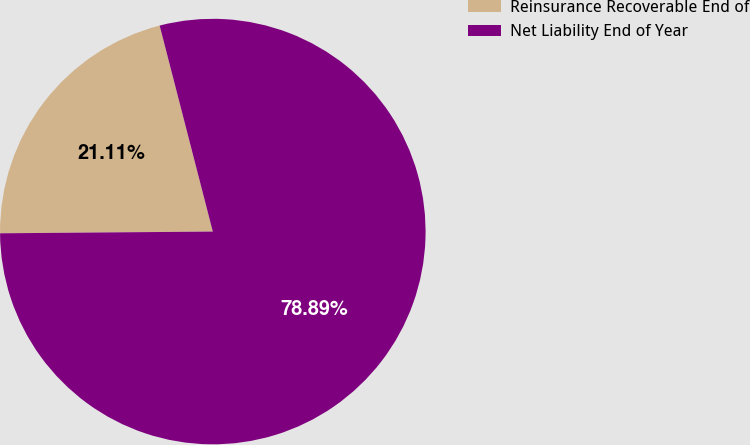<chart> <loc_0><loc_0><loc_500><loc_500><pie_chart><fcel>Reinsurance Recoverable End of<fcel>Net Liability End of Year<nl><fcel>21.11%<fcel>78.89%<nl></chart> 